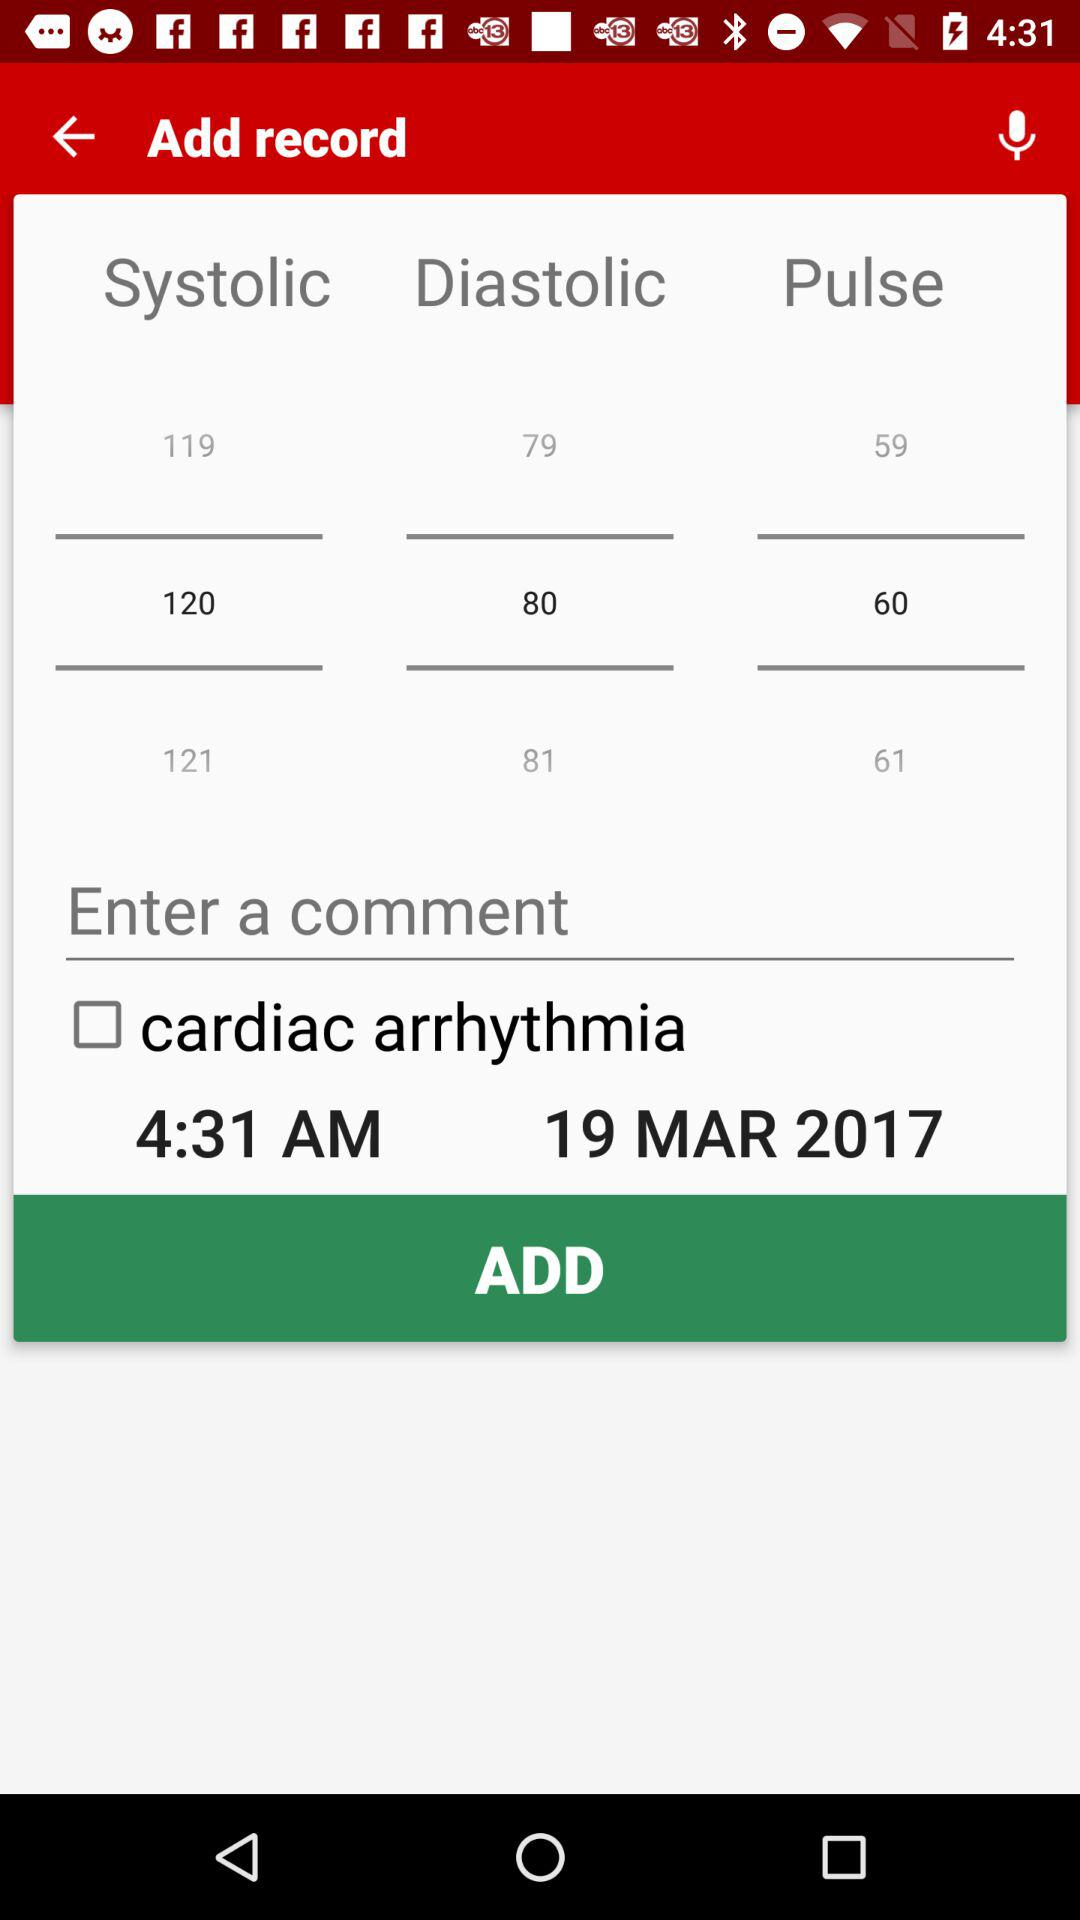Which comment has been entered?
When the provided information is insufficient, respond with <no answer>. <no answer> 